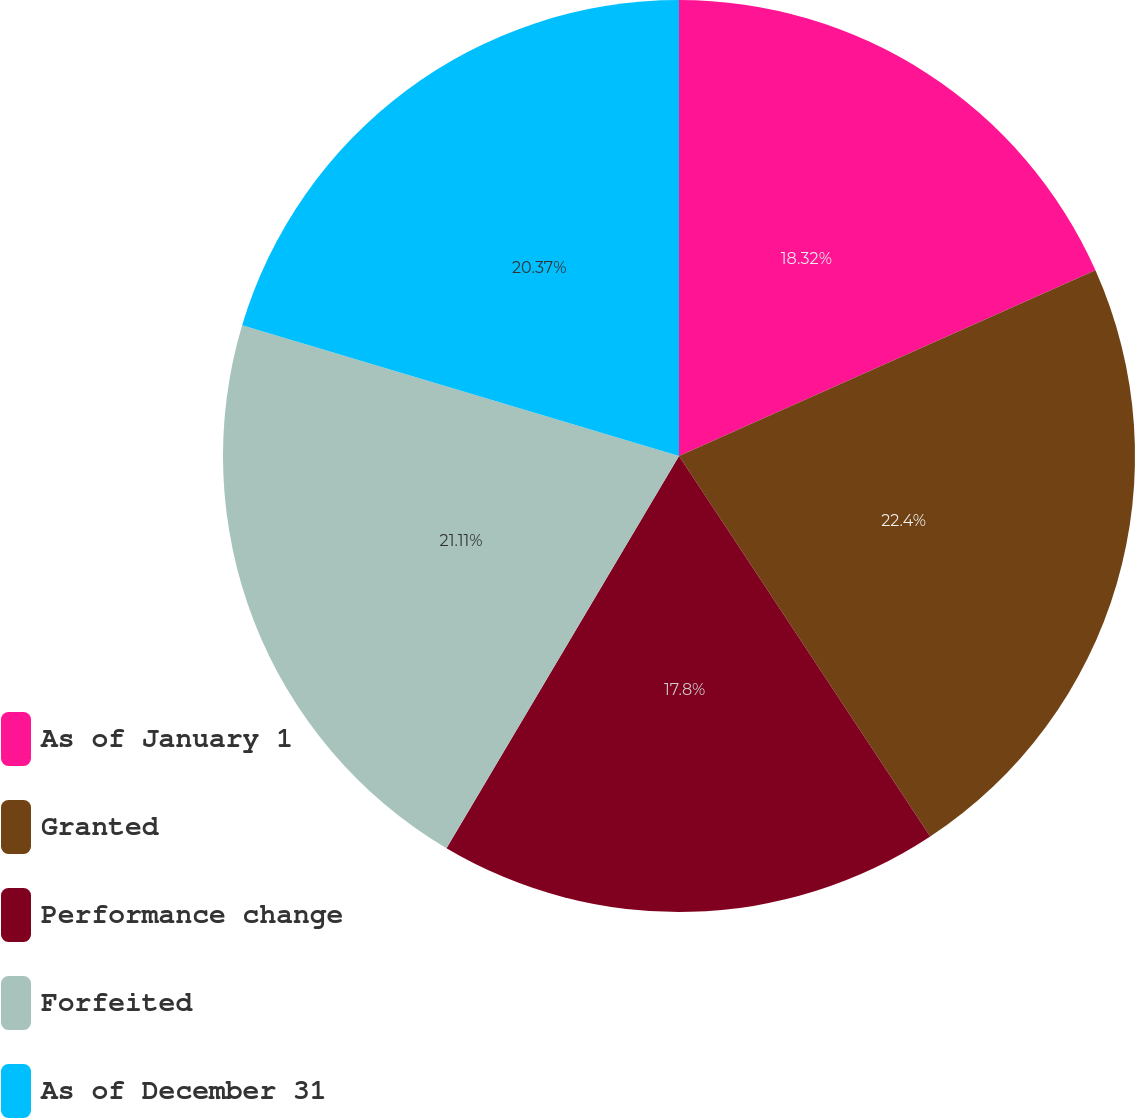Convert chart. <chart><loc_0><loc_0><loc_500><loc_500><pie_chart><fcel>As of January 1<fcel>Granted<fcel>Performance change<fcel>Forfeited<fcel>As of December 31<nl><fcel>18.32%<fcel>22.39%<fcel>17.8%<fcel>21.11%<fcel>20.37%<nl></chart> 